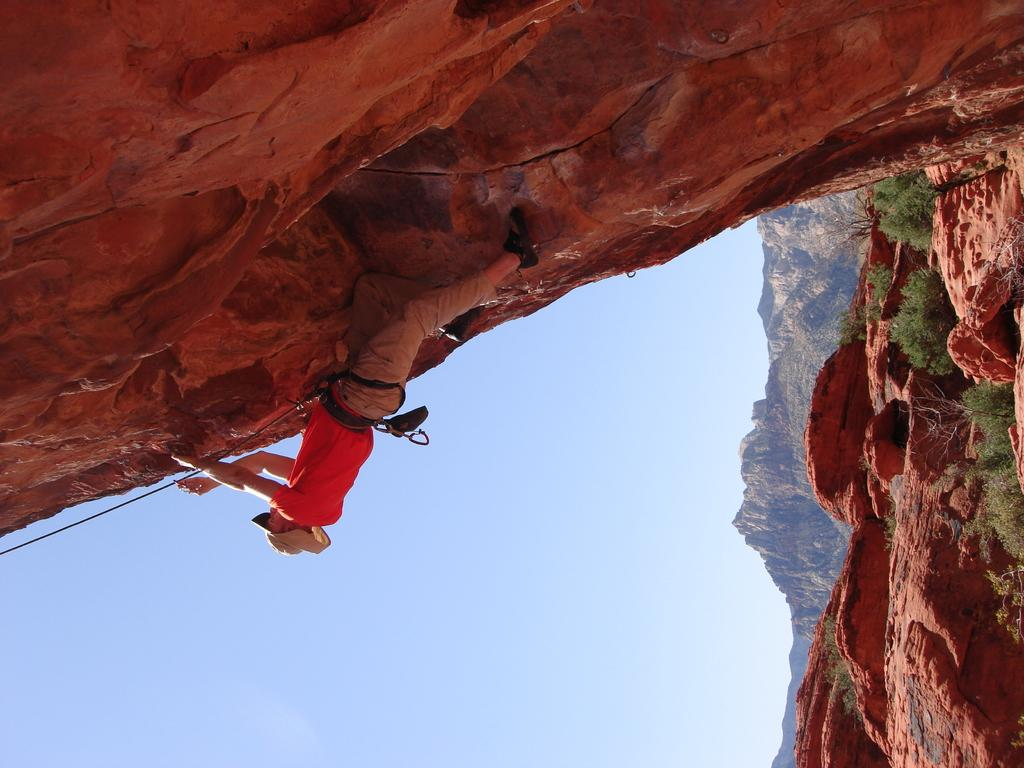What is the man in the image doing? The man is climbing a hill in the image. What is the man holding while climbing the hill? The man is holding a rope in the image. What can be seen on the man's head? The man is wearing a hat in the image. What color is the man's T-shirt? The man is wearing a red T-shirt in the image. What type of pants is the man wearing? The man is wearing trousers in the image. What type of footwear is the man wearing? The man is wearing shoes in the image. What type of vegetation is present in the image? There are small trees in the image. How many visitors are present in the image? There is no mention of visitors in the image; it only features a man climbing a hill. What type of hose is the man using to climb the hill? There is no hose present in the image; the man is holding a rope. 